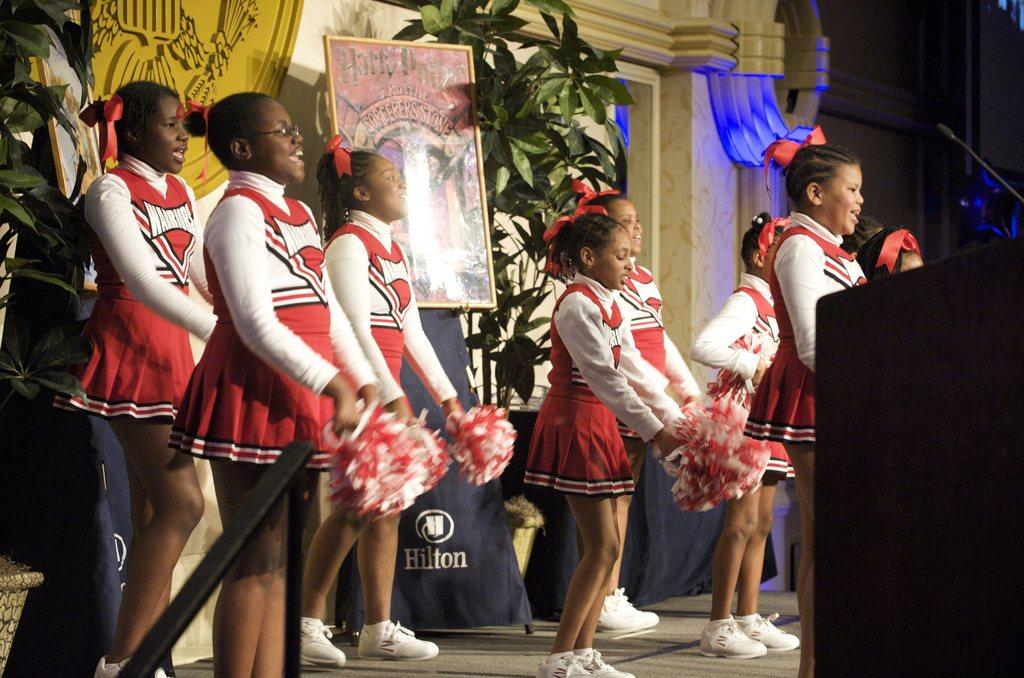<image>
Provide a brief description of the given image. The book title on the sign behind the cheerleaders is Harry Potter and the Sorcerer's Stone 